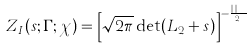Convert formula to latex. <formula><loc_0><loc_0><loc_500><loc_500>Z _ { I } ( s ; \Gamma ; \chi ) = \left [ \sqrt { 2 \pi } \det ( L _ { 2 } + s ) \right ] ^ { - \frac { n | F | } { 2 \pi } }</formula> 